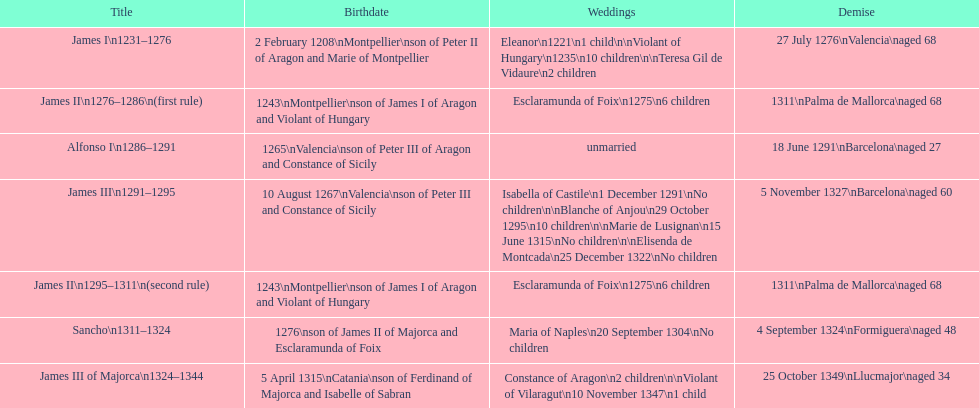Was james iii or sancho born in the year 1276? Sancho. 